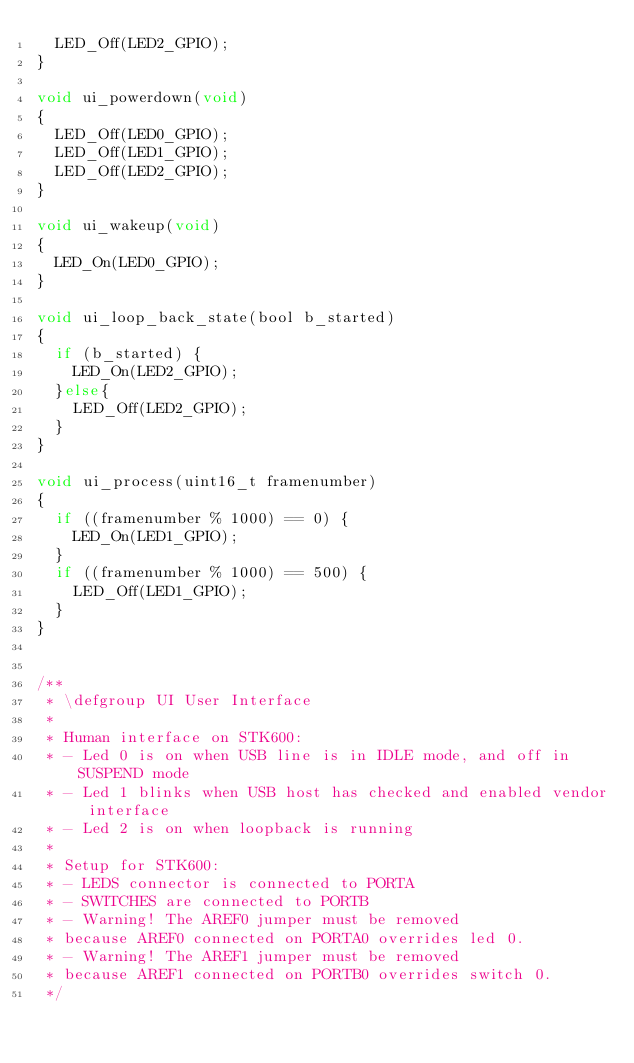Convert code to text. <code><loc_0><loc_0><loc_500><loc_500><_C_>	LED_Off(LED2_GPIO);
}

void ui_powerdown(void)
{
	LED_Off(LED0_GPIO);
	LED_Off(LED1_GPIO);
	LED_Off(LED2_GPIO);
}

void ui_wakeup(void)
{
	LED_On(LED0_GPIO);
}

void ui_loop_back_state(bool b_started)
{
	if (b_started) {
		LED_On(LED2_GPIO);
	}else{
		LED_Off(LED2_GPIO);
	}
}

void ui_process(uint16_t framenumber)
{
	if ((framenumber % 1000) == 0) {
		LED_On(LED1_GPIO);
	}
	if ((framenumber % 1000) == 500) {
		LED_Off(LED1_GPIO);
	}
}


/**
 * \defgroup UI User Interface
 *
 * Human interface on STK600:
 * - Led 0 is on when USB line is in IDLE mode, and off in SUSPEND mode
 * - Led 1 blinks when USB host has checked and enabled vendor interface
 * - Led 2 is on when loopback is running
 *
 * Setup for STK600:
 * - LEDS connector is connected to PORTA
 * - SWITCHES are connected to PORTB
 * - Warning! The AREF0 jumper must be removed
 * because AREF0 connected on PORTA0 overrides led 0.
 * - Warning! The AREF1 jumper must be removed
 * because AREF1 connected on PORTB0 overrides switch 0.
 */
</code> 